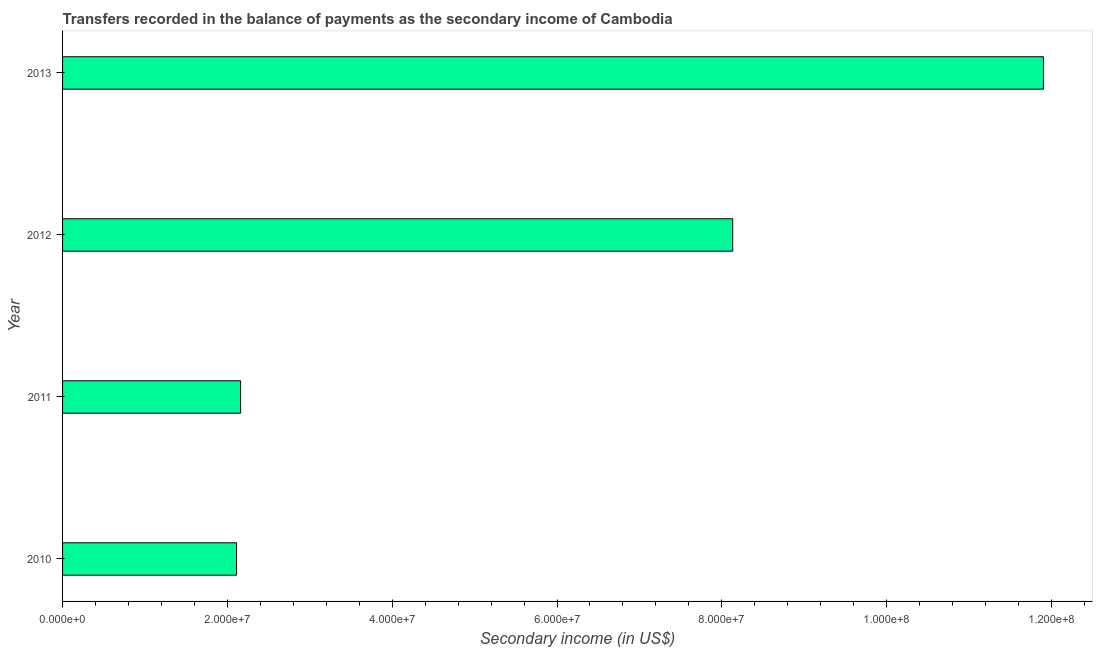Does the graph contain any zero values?
Your answer should be compact. No. What is the title of the graph?
Give a very brief answer. Transfers recorded in the balance of payments as the secondary income of Cambodia. What is the label or title of the X-axis?
Provide a succinct answer. Secondary income (in US$). What is the label or title of the Y-axis?
Make the answer very short. Year. What is the amount of secondary income in 2010?
Provide a short and direct response. 2.11e+07. Across all years, what is the maximum amount of secondary income?
Offer a terse response. 1.19e+08. Across all years, what is the minimum amount of secondary income?
Give a very brief answer. 2.11e+07. In which year was the amount of secondary income maximum?
Give a very brief answer. 2013. What is the sum of the amount of secondary income?
Offer a very short reply. 2.43e+08. What is the difference between the amount of secondary income in 2011 and 2013?
Your response must be concise. -9.74e+07. What is the average amount of secondary income per year?
Offer a very short reply. 6.08e+07. What is the median amount of secondary income?
Offer a terse response. 5.15e+07. What is the ratio of the amount of secondary income in 2012 to that in 2013?
Offer a terse response. 0.68. Is the amount of secondary income in 2011 less than that in 2013?
Your answer should be very brief. Yes. Is the difference between the amount of secondary income in 2011 and 2013 greater than the difference between any two years?
Provide a succinct answer. No. What is the difference between the highest and the second highest amount of secondary income?
Provide a succinct answer. 3.77e+07. What is the difference between the highest and the lowest amount of secondary income?
Your answer should be compact. 9.79e+07. Are all the bars in the graph horizontal?
Keep it short and to the point. Yes. How many years are there in the graph?
Give a very brief answer. 4. What is the difference between two consecutive major ticks on the X-axis?
Your response must be concise. 2.00e+07. Are the values on the major ticks of X-axis written in scientific E-notation?
Your response must be concise. Yes. What is the Secondary income (in US$) of 2010?
Give a very brief answer. 2.11e+07. What is the Secondary income (in US$) of 2011?
Provide a short and direct response. 2.16e+07. What is the Secondary income (in US$) in 2012?
Offer a terse response. 8.13e+07. What is the Secondary income (in US$) of 2013?
Your answer should be compact. 1.19e+08. What is the difference between the Secondary income (in US$) in 2010 and 2011?
Your response must be concise. -4.89e+05. What is the difference between the Secondary income (in US$) in 2010 and 2012?
Offer a terse response. -6.02e+07. What is the difference between the Secondary income (in US$) in 2010 and 2013?
Provide a short and direct response. -9.79e+07. What is the difference between the Secondary income (in US$) in 2011 and 2012?
Offer a terse response. -5.97e+07. What is the difference between the Secondary income (in US$) in 2011 and 2013?
Provide a succinct answer. -9.74e+07. What is the difference between the Secondary income (in US$) in 2012 and 2013?
Offer a terse response. -3.77e+07. What is the ratio of the Secondary income (in US$) in 2010 to that in 2012?
Keep it short and to the point. 0.26. What is the ratio of the Secondary income (in US$) in 2010 to that in 2013?
Ensure brevity in your answer.  0.18. What is the ratio of the Secondary income (in US$) in 2011 to that in 2012?
Provide a succinct answer. 0.27. What is the ratio of the Secondary income (in US$) in 2011 to that in 2013?
Your answer should be compact. 0.18. What is the ratio of the Secondary income (in US$) in 2012 to that in 2013?
Offer a very short reply. 0.68. 